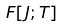<formula> <loc_0><loc_0><loc_500><loc_500>F [ J ; T ]</formula> 